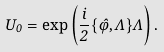<formula> <loc_0><loc_0><loc_500><loc_500>U _ { 0 } = \exp \left ( \frac { i } { 2 } \{ \hat { \varphi } , \Lambda \} \Lambda \right ) .</formula> 